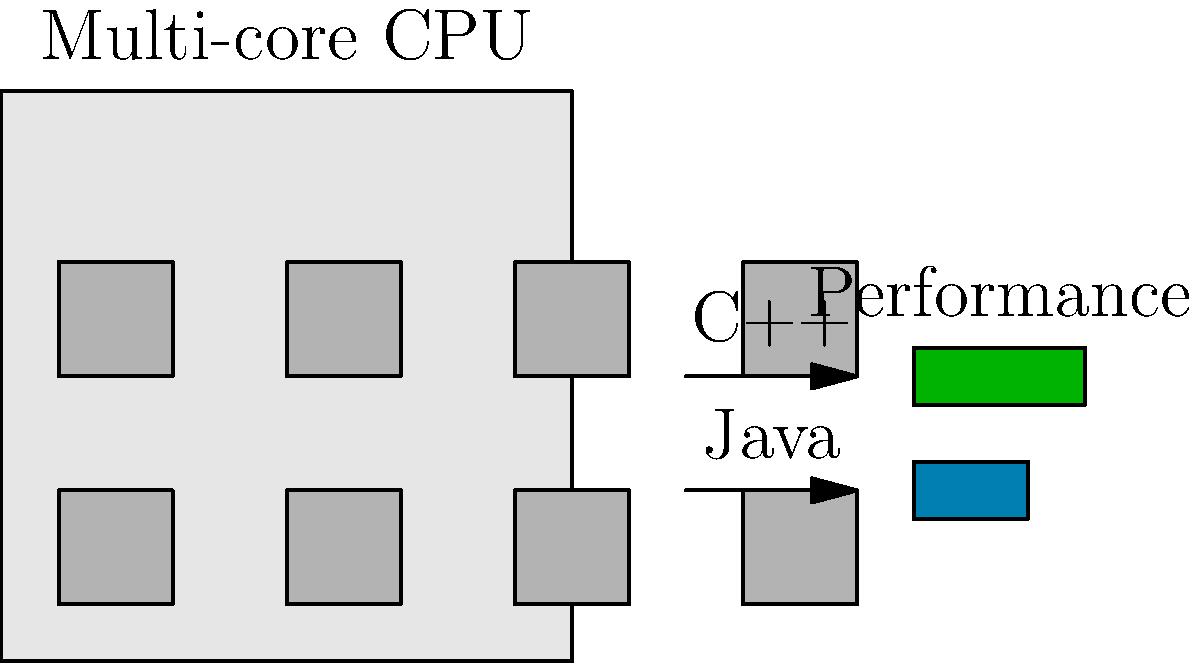Based on the multi-core CPU diagram and the performance comparison between C++ and Java, which language is likely to have better parallel processing capabilities for high-performance computing tasks, and why? To answer this question, we need to consider several factors:

1. Multi-core CPU architecture: The diagram shows a CPU with 8 cores, indicating support for parallel processing.

2. Language characteristics:
   a. C++: 
      - Provides low-level hardware access
      - Allows fine-grained control over memory management
      - Supports various parallel programming models (e.g., OpenMP, MPI)
   b. Java:
      - Runs on a virtual machine (JVM)
      - Has automatic memory management (garbage collection)
      - Provides built-in support for concurrency (e.g., java.util.concurrent package)

3. Performance comparison: The diagram shows C++ with a longer performance bar compared to Java.

4. High-performance computing (HPC) requirements:
   - Direct hardware access
   - Fine-tuned memory management
   - Minimal overhead

5. Parallel processing capabilities:
   - C++ allows direct control over thread allocation to specific cores
   - Java's threading model is more abstracted, relying on the JVM for thread management

Considering these factors:

1. C++ provides better low-level control, which is crucial for HPC tasks.
2. The performance bar indicates C++ outperforms Java in this context.
3. C++ allows for more efficient use of the multi-core architecture through direct hardware access.
4. While Java has good built-in concurrency support, its abstraction layer (JVM) can introduce overhead in HPC scenarios.

Therefore, C++ is likely to have better parallel processing capabilities for high-performance computing tasks on this multi-core CPU.
Answer: C++, due to low-level hardware access, fine-grained control, and lower overhead. 